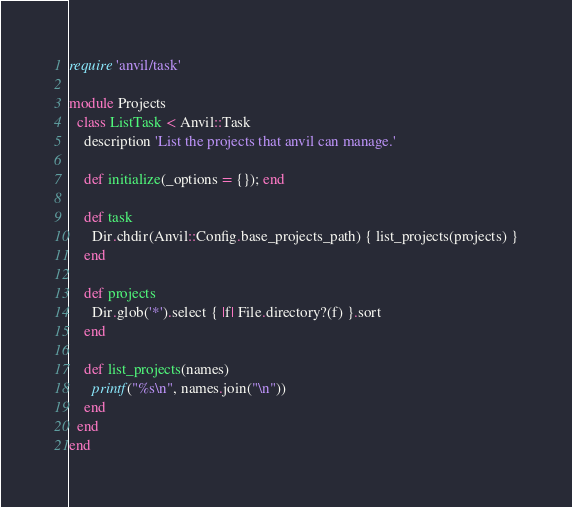<code> <loc_0><loc_0><loc_500><loc_500><_Ruby_>require 'anvil/task'

module Projects
  class ListTask < Anvil::Task
    description 'List the projects that anvil can manage.'

    def initialize(_options = {}); end

    def task
      Dir.chdir(Anvil::Config.base_projects_path) { list_projects(projects) }
    end

    def projects
      Dir.glob('*').select { |f| File.directory?(f) }.sort
    end

    def list_projects(names)
      printf("%s\n", names.join("\n"))
    end
  end
end
</code> 